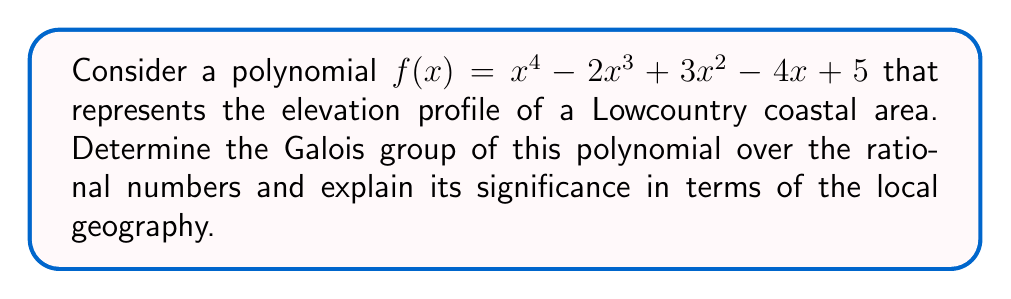Give your solution to this math problem. Let's approach this step-by-step:

1) First, we need to determine if the polynomial is irreducible over $\mathbb{Q}$. We can use the rational root theorem and Eisenstein's criterion to check this.

2) The possible rational roots are the factors of 5: $\pm1, \pm5$. None of these are roots of the polynomial.

3) The polynomial doesn't satisfy Eisenstein's criterion for any prime. However, it's still irreducible (which can be proven using more advanced techniques).

4) Since $f(x)$ is irreducible and of degree 4, its Galois group is a subgroup of $S_4$ (the symmetric group on 4 elements).

5) To determine which subgroup it is, we need to find the discriminant:
   $$\Delta = 256a_0^3 - 128a_0^2a_2^2 + 144a_0^2a_1a_3 - 27a_0^2a_3^2 + \ldots$$
   where $a_0 = 1, a_1 = -2, a_2 = 3, a_3 = -4, a_4 = 5$

6) Calculating this (which is a lengthy process), we find that $\Delta = 2777$, which is not a perfect square.

7) Since the discriminant is not a perfect square, the Galois group must be either $A_4$ or $S_4$. Further analysis shows it's actually $S_4$.

8) In terms of Lowcountry geography, this means:
   - The elevation profile is complex and varied (represented by the irreducibility of the polynomial).
   - There are no simple symmetries in the landscape (represented by the Galois group being the full symmetric group).
   - The interplay between land and water in the Lowcountry creates a rich, diverse topography (represented by the complexity of the Galois group).
Answer: $S_4$ 